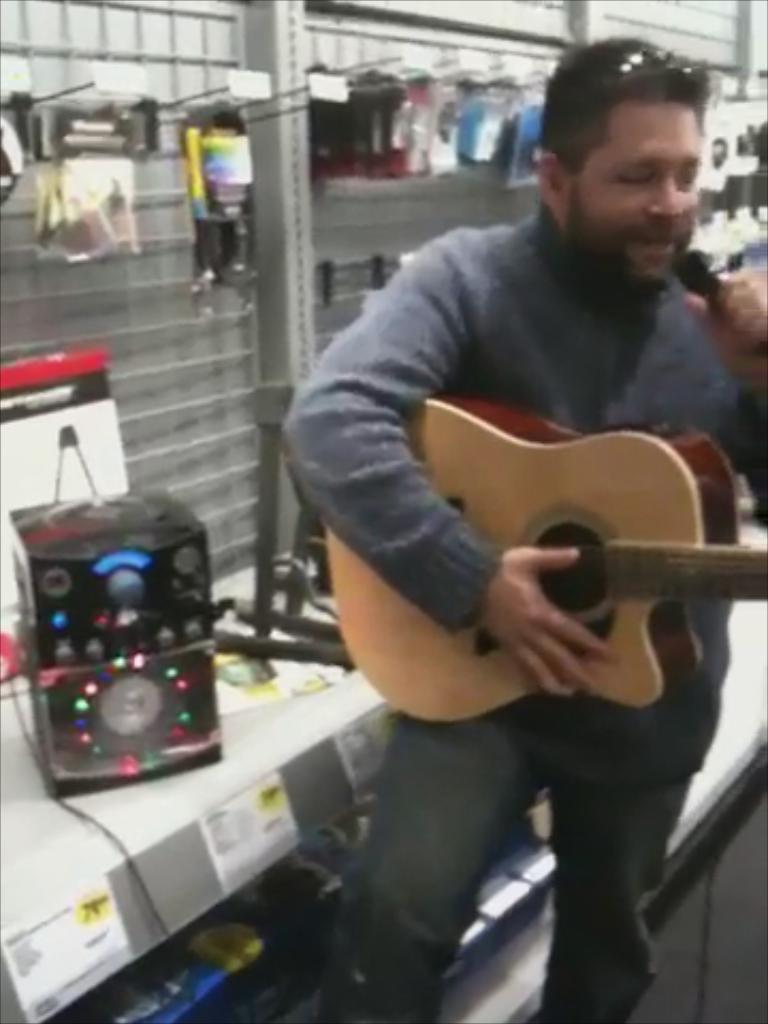Describe this image in one or two sentences. This is the picture taken in a room, the man is standing and holding a guitar and singing a song and the man is also holding a microphone. Behind the man there is a shelf with different items. 